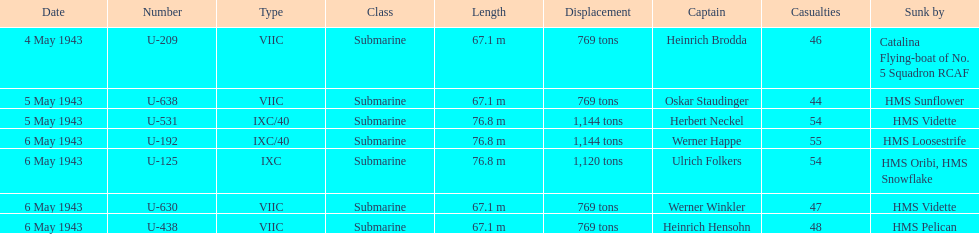Aside from oskar staudinger what was the name of the other captain of the u-boat loast on may 5? Herbert Neckel. 